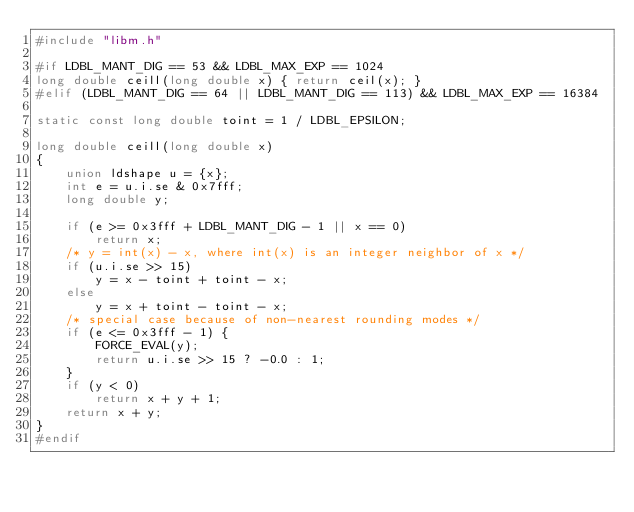Convert code to text. <code><loc_0><loc_0><loc_500><loc_500><_C_>#include "libm.h"

#if LDBL_MANT_DIG == 53 && LDBL_MAX_EXP == 1024
long double ceill(long double x) { return ceil(x); }
#elif (LDBL_MANT_DIG == 64 || LDBL_MANT_DIG == 113) && LDBL_MAX_EXP == 16384

static const long double toint = 1 / LDBL_EPSILON;

long double ceill(long double x)
{
    union ldshape u = {x};
    int e = u.i.se & 0x7fff;
    long double y;

    if (e >= 0x3fff + LDBL_MANT_DIG - 1 || x == 0)
        return x;
    /* y = int(x) - x, where int(x) is an integer neighbor of x */
    if (u.i.se >> 15)
        y = x - toint + toint - x;
    else
        y = x + toint - toint - x;
    /* special case because of non-nearest rounding modes */
    if (e <= 0x3fff - 1) {
        FORCE_EVAL(y);
        return u.i.se >> 15 ? -0.0 : 1;
    }
    if (y < 0)
        return x + y + 1;
    return x + y;
}
#endif
</code> 